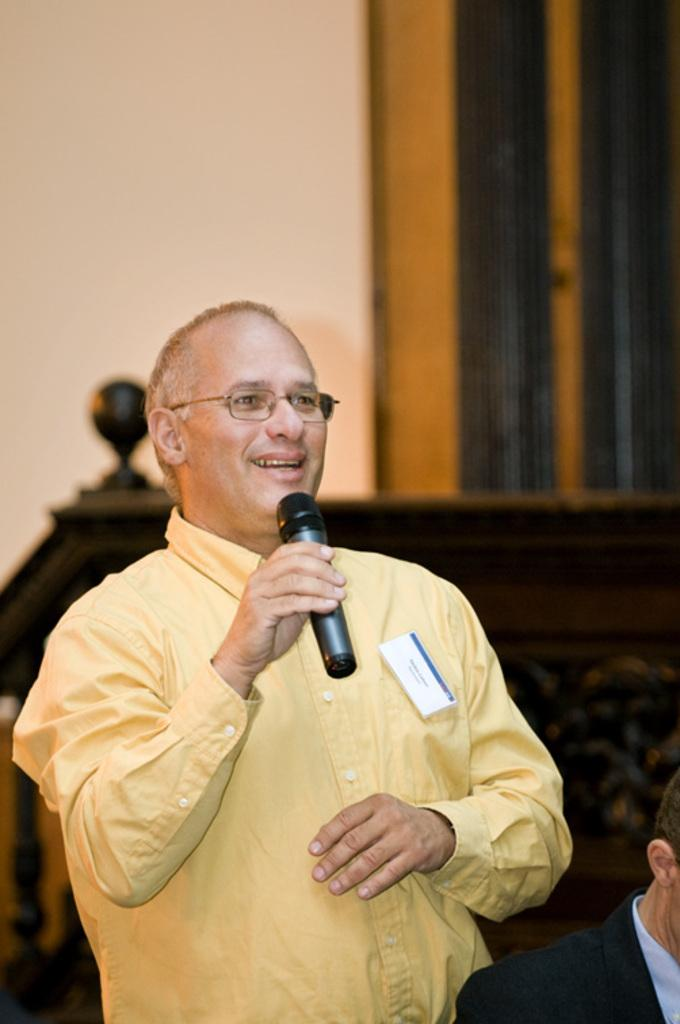What is the man in the image doing? The man is standing and holding a microphone. What is the man's facial expression in the image? The man is smiling. Can you describe the position of the other man in the image? There is another man sitting in front of the standing man. What type of yam is the man holding in the image? There is no yam present in the image; the man is holding a microphone. 